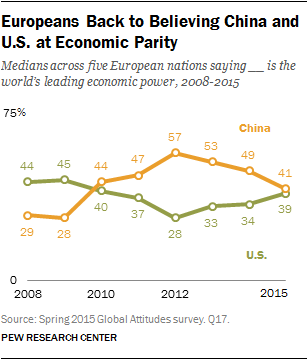Specify some key components in this picture. The leftmost value of the green graph is 44. The sum of the two lowest values of the green graph is greater than the highest value of the orange graph. 